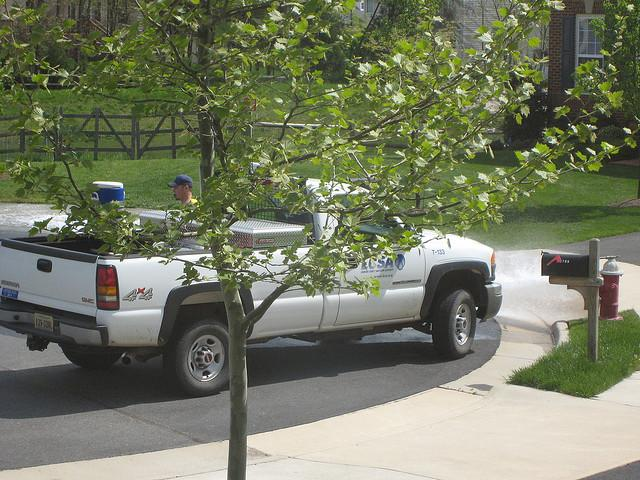What does he do?

Choices:
A) parks vehicles
B) cleans trucks
C) haircuts
D) landscaping landscaping 